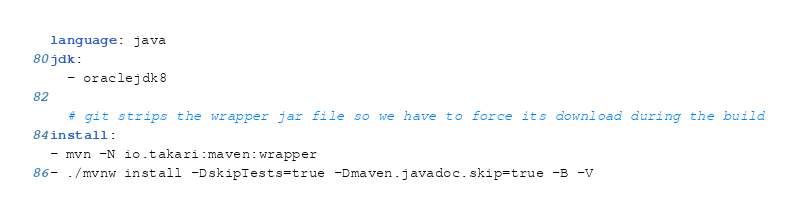<code> <loc_0><loc_0><loc_500><loc_500><_YAML_>language: java
jdk:
  - oraclejdk8
  
  # git strips the wrapper jar file so we have to force its download during the build
install:
- mvn -N io.takari:maven:wrapper
- ./mvnw install -DskipTests=true -Dmaven.javadoc.skip=true -B -V
</code> 